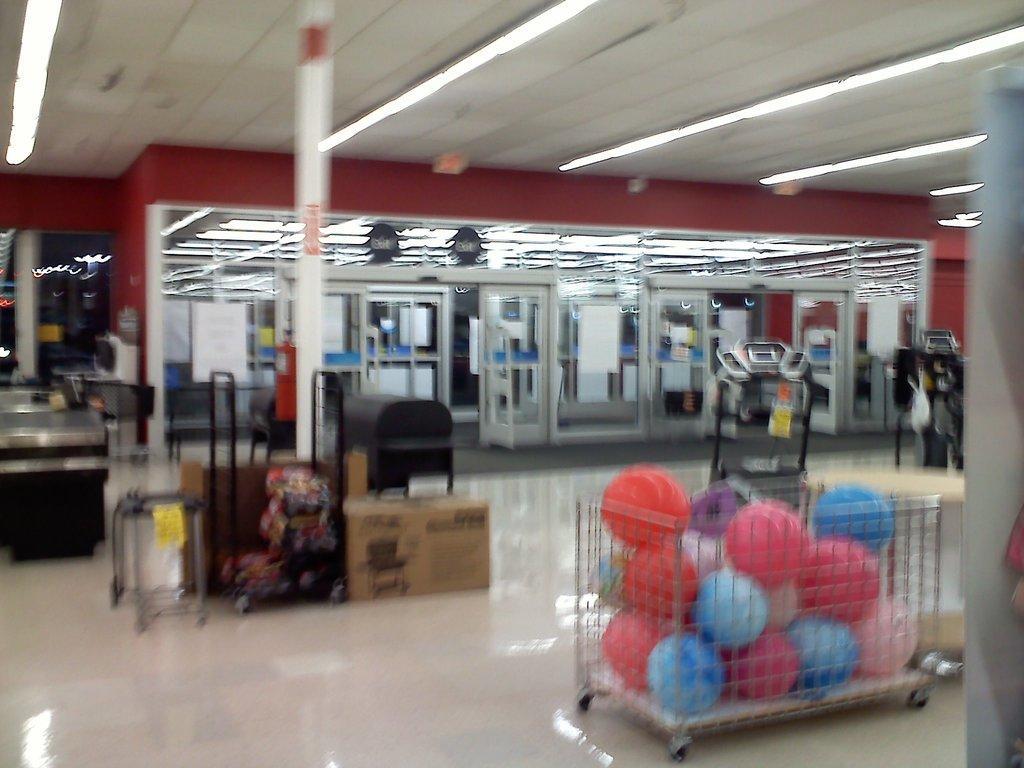Please provide a concise description of this image. In this image, we can see the inner view of a store. We can see the ground with some objects. We can also see the wall with some objects. We can see some glass doors. We can see some balls in a trolley. We can see some poles and the roof with some lights. 